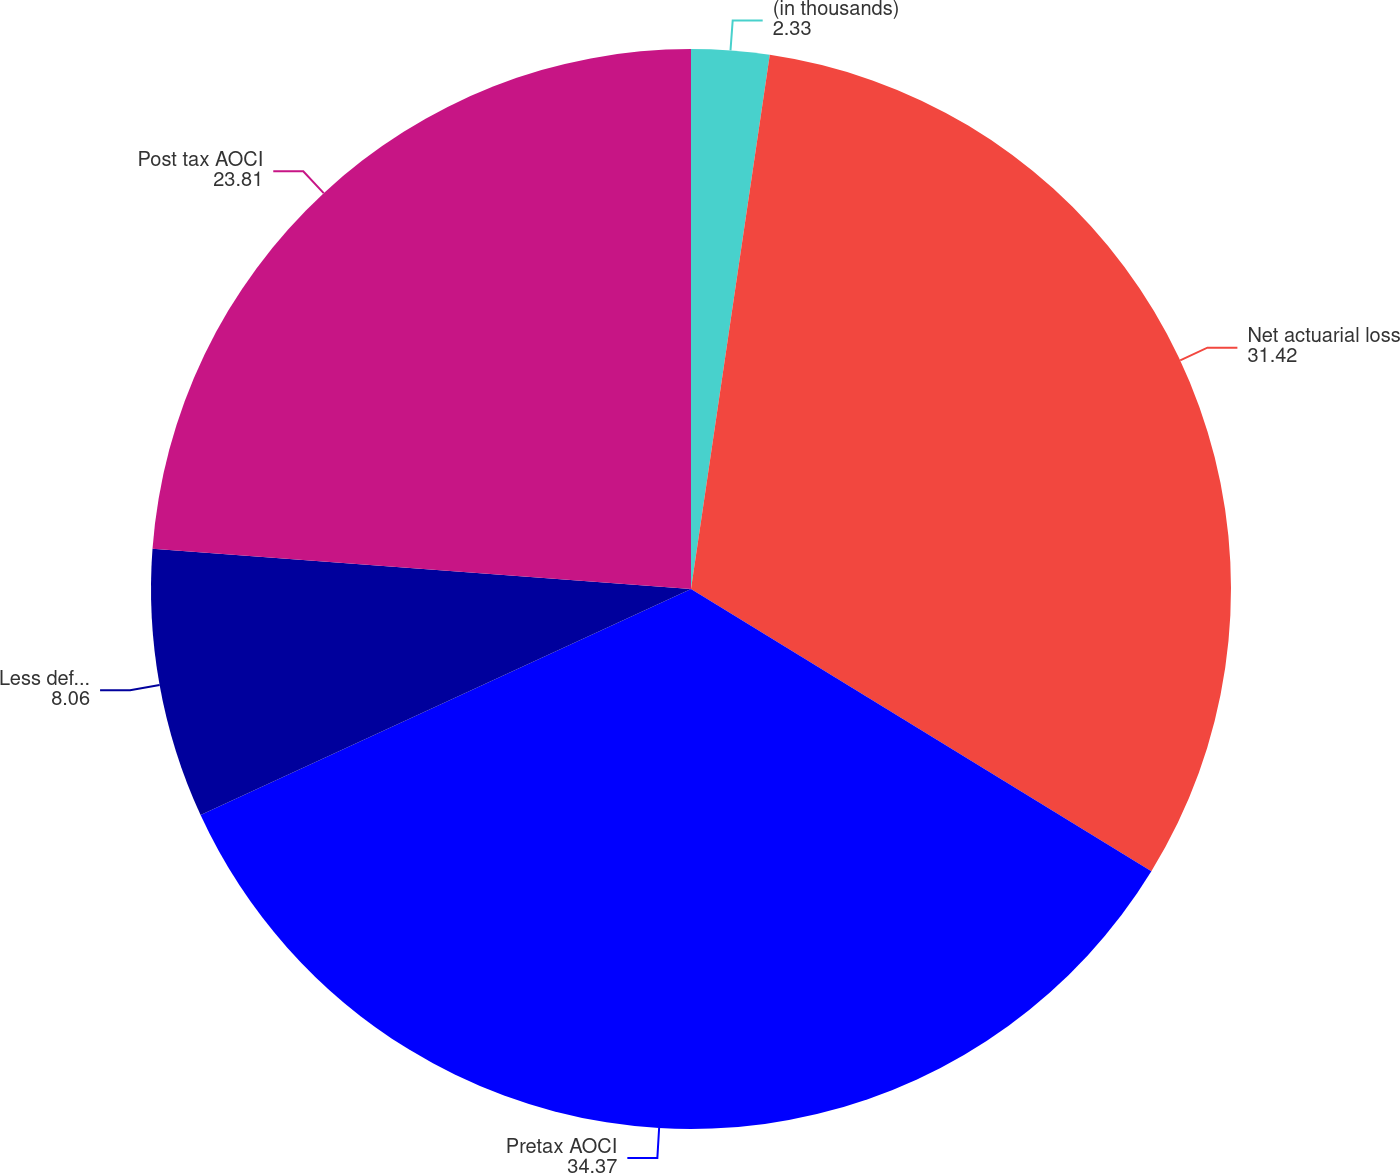Convert chart. <chart><loc_0><loc_0><loc_500><loc_500><pie_chart><fcel>(in thousands)<fcel>Net actuarial loss<fcel>Pretax AOCI<fcel>Less deferred taxes<fcel>Post tax AOCI<nl><fcel>2.33%<fcel>31.42%<fcel>34.37%<fcel>8.06%<fcel>23.81%<nl></chart> 